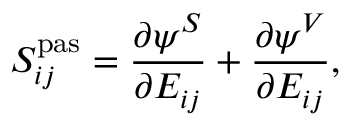<formula> <loc_0><loc_0><loc_500><loc_500>S _ { i j } ^ { p a s } = \frac { \partial \psi ^ { S } } { \partial E _ { i j } } + \frac { \partial \psi ^ { V } } { \partial E _ { i j } } ,</formula> 